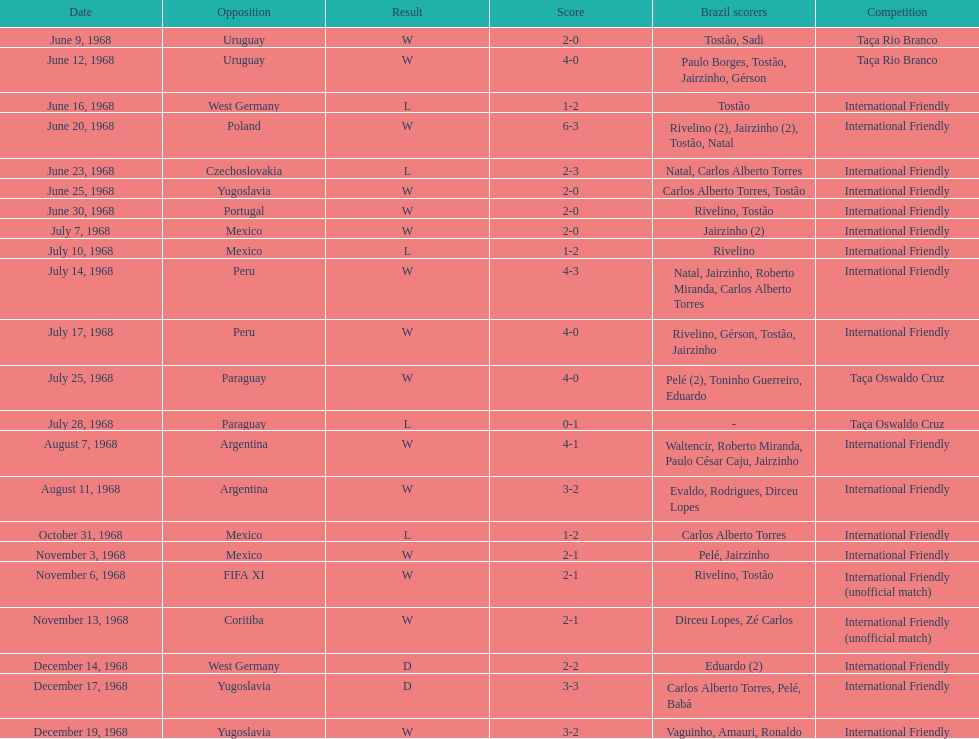What was the total number of goals scored by brazil in the match on november 6th? 2. 